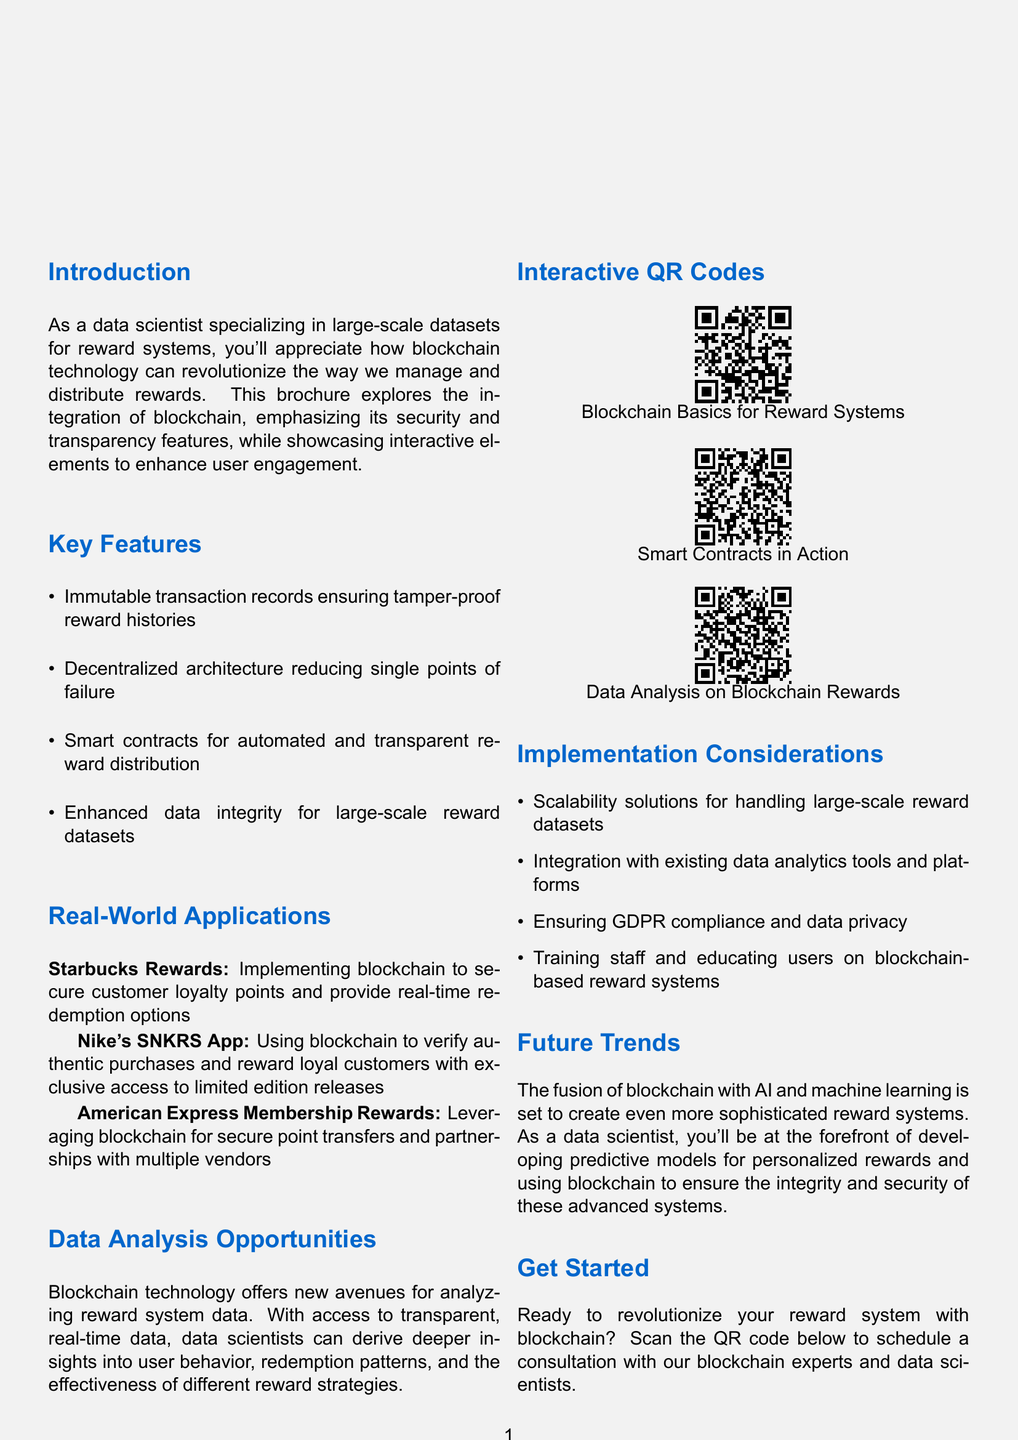What is the title of the brochure? The title is prominently displayed at the beginning of the document, introducing the main theme of the content.
Answer: Blockchain-Powered Reward Systems: Secure, Transparent, and Interactive What feature ensures tamper-proof reward histories? This feature is one of the key elements highlighted in the brochure under the section discussing benefits of blockchain.
Answer: Immutable transaction records Which app uses blockchain to verify authentic purchases? This is mentioned in the Real-World Applications section, showcasing a specific use case of blockchain technology.
Answer: Nike's SNKRS App How many interactive QR codes are included in the brochure? The brochure features several interactive elements with QR codes linked to demo videos, indicating user engagement opportunities.
Answer: Three What is one consideration for implementing blockchain in reward systems? This information is listed under the Implementation Considerations section, providing insights on effective integration.
Answer: Scalability solutions What is a future trend mentioned in the document? The document discusses upcoming advancements that will impact reward systems, specifically in the context of blockchain technology.
Answer: Fusion of blockchain with AI and machine learning What type of contracts are highlighted for automated distribution? This term refers to a specific technological function that blockchain supports, aiding in the efficiency of reward distribution.
Answer: Smart contracts What call to action is provided at the end of the brochure? The conclusion invites readers to take a step towards engaging with the service offered in the brochure.
Answer: Scan the QR code below to schedule a consultation with our blockchain experts and data scientists 